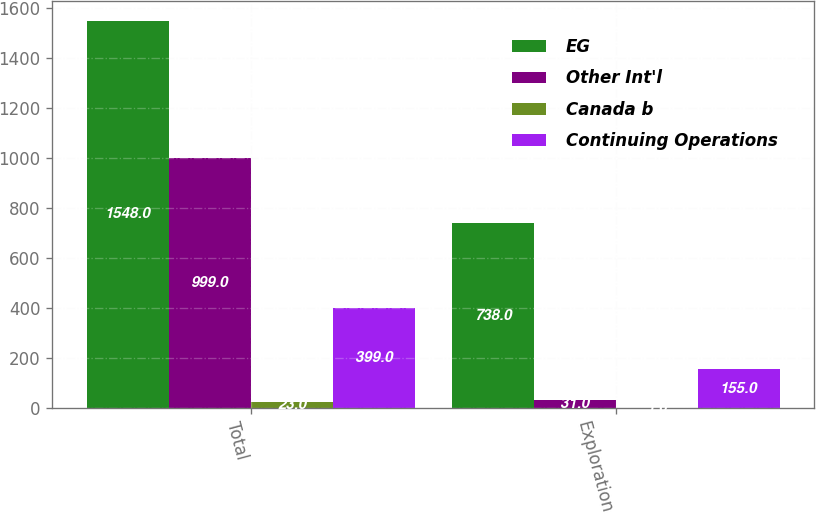Convert chart. <chart><loc_0><loc_0><loc_500><loc_500><stacked_bar_chart><ecel><fcel>Total<fcel>Exploration<nl><fcel>EG<fcel>1548<fcel>738<nl><fcel>Other Int'l<fcel>999<fcel>31<nl><fcel>Canada b<fcel>23<fcel>1<nl><fcel>Continuing Operations<fcel>399<fcel>155<nl></chart> 